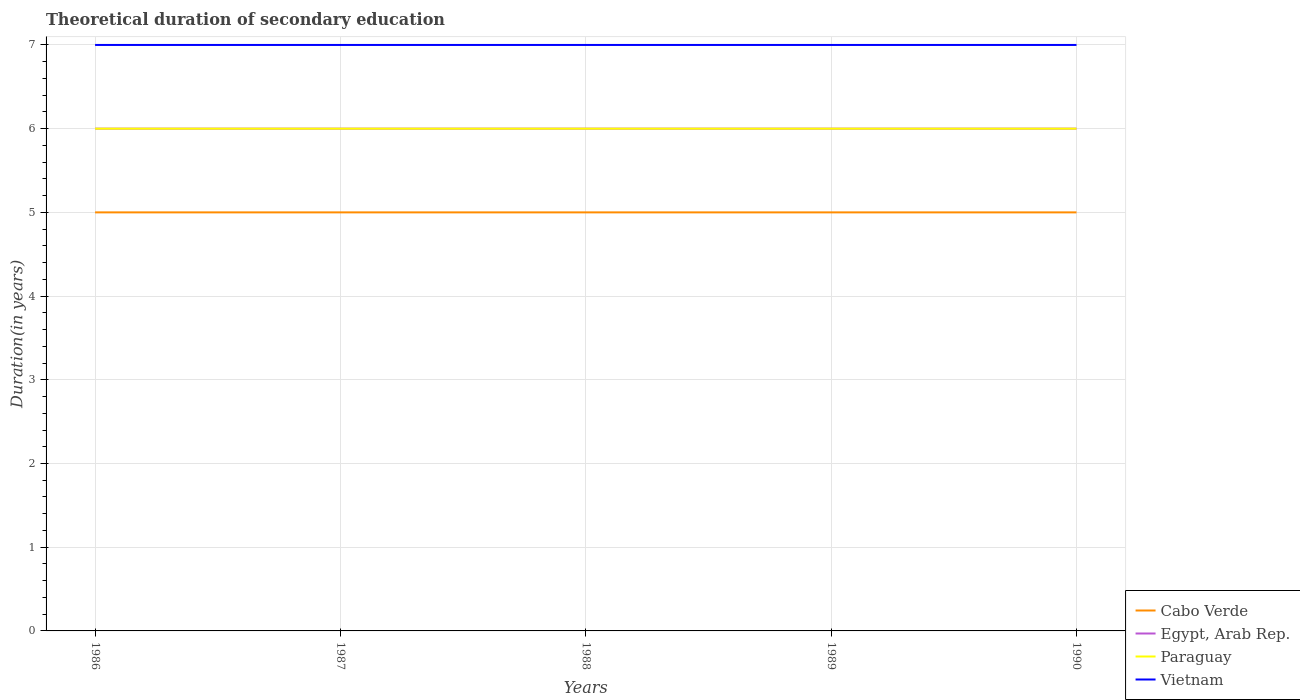Across all years, what is the maximum total theoretical duration of secondary education in Vietnam?
Your answer should be compact. 7. In which year was the total theoretical duration of secondary education in Egypt, Arab Rep. maximum?
Provide a succinct answer. 1986. Is the total theoretical duration of secondary education in Paraguay strictly greater than the total theoretical duration of secondary education in Egypt, Arab Rep. over the years?
Your answer should be compact. No. How many lines are there?
Provide a short and direct response. 4. What is the difference between two consecutive major ticks on the Y-axis?
Your answer should be very brief. 1. Are the values on the major ticks of Y-axis written in scientific E-notation?
Provide a short and direct response. No. How are the legend labels stacked?
Provide a short and direct response. Vertical. What is the title of the graph?
Offer a very short reply. Theoretical duration of secondary education. Does "Heavily indebted poor countries" appear as one of the legend labels in the graph?
Provide a short and direct response. No. What is the label or title of the Y-axis?
Provide a succinct answer. Duration(in years). What is the Duration(in years) in Cabo Verde in 1986?
Your answer should be very brief. 5. What is the Duration(in years) in Paraguay in 1986?
Your answer should be very brief. 6. What is the Duration(in years) of Vietnam in 1986?
Make the answer very short. 7. What is the Duration(in years) in Egypt, Arab Rep. in 1987?
Keep it short and to the point. 6. What is the Duration(in years) in Paraguay in 1987?
Your answer should be compact. 6. What is the Duration(in years) of Vietnam in 1987?
Provide a short and direct response. 7. What is the Duration(in years) of Egypt, Arab Rep. in 1988?
Provide a succinct answer. 6. What is the Duration(in years) of Paraguay in 1988?
Offer a very short reply. 6. What is the Duration(in years) in Paraguay in 1989?
Provide a short and direct response. 6. What is the Duration(in years) of Egypt, Arab Rep. in 1990?
Your answer should be very brief. 6. What is the Duration(in years) in Vietnam in 1990?
Keep it short and to the point. 7. Across all years, what is the maximum Duration(in years) of Cabo Verde?
Ensure brevity in your answer.  5. Across all years, what is the maximum Duration(in years) of Egypt, Arab Rep.?
Offer a very short reply. 6. Across all years, what is the minimum Duration(in years) of Paraguay?
Your answer should be very brief. 6. Across all years, what is the minimum Duration(in years) of Vietnam?
Make the answer very short. 7. What is the total Duration(in years) in Cabo Verde in the graph?
Make the answer very short. 25. What is the total Duration(in years) of Paraguay in the graph?
Your answer should be very brief. 30. What is the difference between the Duration(in years) of Egypt, Arab Rep. in 1986 and that in 1987?
Provide a short and direct response. 0. What is the difference between the Duration(in years) in Vietnam in 1986 and that in 1987?
Your response must be concise. 0. What is the difference between the Duration(in years) of Cabo Verde in 1986 and that in 1988?
Ensure brevity in your answer.  0. What is the difference between the Duration(in years) of Egypt, Arab Rep. in 1986 and that in 1988?
Provide a short and direct response. 0. What is the difference between the Duration(in years) in Paraguay in 1986 and that in 1988?
Provide a short and direct response. 0. What is the difference between the Duration(in years) of Vietnam in 1986 and that in 1988?
Provide a short and direct response. 0. What is the difference between the Duration(in years) in Cabo Verde in 1986 and that in 1989?
Your answer should be compact. 0. What is the difference between the Duration(in years) in Egypt, Arab Rep. in 1986 and that in 1989?
Give a very brief answer. 0. What is the difference between the Duration(in years) in Cabo Verde in 1986 and that in 1990?
Your answer should be compact. 0. What is the difference between the Duration(in years) in Egypt, Arab Rep. in 1986 and that in 1990?
Provide a succinct answer. 0. What is the difference between the Duration(in years) in Vietnam in 1986 and that in 1990?
Provide a succinct answer. 0. What is the difference between the Duration(in years) of Egypt, Arab Rep. in 1987 and that in 1988?
Make the answer very short. 0. What is the difference between the Duration(in years) of Paraguay in 1987 and that in 1988?
Offer a very short reply. 0. What is the difference between the Duration(in years) of Cabo Verde in 1987 and that in 1989?
Provide a short and direct response. 0. What is the difference between the Duration(in years) in Vietnam in 1987 and that in 1989?
Your answer should be very brief. 0. What is the difference between the Duration(in years) of Cabo Verde in 1987 and that in 1990?
Provide a succinct answer. 0. What is the difference between the Duration(in years) in Egypt, Arab Rep. in 1987 and that in 1990?
Make the answer very short. 0. What is the difference between the Duration(in years) of Paraguay in 1987 and that in 1990?
Provide a short and direct response. 0. What is the difference between the Duration(in years) in Egypt, Arab Rep. in 1988 and that in 1989?
Offer a very short reply. 0. What is the difference between the Duration(in years) in Vietnam in 1988 and that in 1989?
Give a very brief answer. 0. What is the difference between the Duration(in years) of Cabo Verde in 1988 and that in 1990?
Offer a terse response. 0. What is the difference between the Duration(in years) in Vietnam in 1988 and that in 1990?
Ensure brevity in your answer.  0. What is the difference between the Duration(in years) of Cabo Verde in 1986 and the Duration(in years) of Egypt, Arab Rep. in 1987?
Your answer should be compact. -1. What is the difference between the Duration(in years) of Cabo Verde in 1986 and the Duration(in years) of Paraguay in 1987?
Your answer should be compact. -1. What is the difference between the Duration(in years) in Cabo Verde in 1986 and the Duration(in years) in Vietnam in 1987?
Give a very brief answer. -2. What is the difference between the Duration(in years) of Egypt, Arab Rep. in 1986 and the Duration(in years) of Vietnam in 1987?
Offer a very short reply. -1. What is the difference between the Duration(in years) in Paraguay in 1986 and the Duration(in years) in Vietnam in 1987?
Keep it short and to the point. -1. What is the difference between the Duration(in years) of Cabo Verde in 1986 and the Duration(in years) of Paraguay in 1988?
Your answer should be compact. -1. What is the difference between the Duration(in years) in Egypt, Arab Rep. in 1986 and the Duration(in years) in Paraguay in 1988?
Ensure brevity in your answer.  0. What is the difference between the Duration(in years) of Egypt, Arab Rep. in 1986 and the Duration(in years) of Vietnam in 1988?
Keep it short and to the point. -1. What is the difference between the Duration(in years) in Cabo Verde in 1986 and the Duration(in years) in Egypt, Arab Rep. in 1989?
Offer a very short reply. -1. What is the difference between the Duration(in years) of Cabo Verde in 1986 and the Duration(in years) of Paraguay in 1989?
Your response must be concise. -1. What is the difference between the Duration(in years) in Egypt, Arab Rep. in 1986 and the Duration(in years) in Vietnam in 1989?
Make the answer very short. -1. What is the difference between the Duration(in years) in Paraguay in 1986 and the Duration(in years) in Vietnam in 1989?
Make the answer very short. -1. What is the difference between the Duration(in years) in Cabo Verde in 1986 and the Duration(in years) in Paraguay in 1990?
Offer a terse response. -1. What is the difference between the Duration(in years) of Cabo Verde in 1986 and the Duration(in years) of Vietnam in 1990?
Your answer should be compact. -2. What is the difference between the Duration(in years) of Egypt, Arab Rep. in 1986 and the Duration(in years) of Paraguay in 1990?
Your response must be concise. 0. What is the difference between the Duration(in years) of Paraguay in 1986 and the Duration(in years) of Vietnam in 1990?
Keep it short and to the point. -1. What is the difference between the Duration(in years) in Cabo Verde in 1987 and the Duration(in years) in Egypt, Arab Rep. in 1988?
Your answer should be compact. -1. What is the difference between the Duration(in years) in Egypt, Arab Rep. in 1987 and the Duration(in years) in Paraguay in 1988?
Offer a very short reply. 0. What is the difference between the Duration(in years) of Egypt, Arab Rep. in 1987 and the Duration(in years) of Vietnam in 1988?
Provide a short and direct response. -1. What is the difference between the Duration(in years) of Paraguay in 1987 and the Duration(in years) of Vietnam in 1988?
Provide a succinct answer. -1. What is the difference between the Duration(in years) in Paraguay in 1987 and the Duration(in years) in Vietnam in 1989?
Provide a short and direct response. -1. What is the difference between the Duration(in years) in Cabo Verde in 1987 and the Duration(in years) in Egypt, Arab Rep. in 1990?
Your answer should be compact. -1. What is the difference between the Duration(in years) in Cabo Verde in 1987 and the Duration(in years) in Paraguay in 1990?
Your answer should be compact. -1. What is the difference between the Duration(in years) in Paraguay in 1987 and the Duration(in years) in Vietnam in 1990?
Offer a very short reply. -1. What is the difference between the Duration(in years) of Cabo Verde in 1988 and the Duration(in years) of Paraguay in 1989?
Your answer should be compact. -1. What is the difference between the Duration(in years) of Cabo Verde in 1988 and the Duration(in years) of Vietnam in 1989?
Your answer should be very brief. -2. What is the difference between the Duration(in years) of Egypt, Arab Rep. in 1988 and the Duration(in years) of Paraguay in 1989?
Make the answer very short. 0. What is the difference between the Duration(in years) of Egypt, Arab Rep. in 1988 and the Duration(in years) of Vietnam in 1989?
Give a very brief answer. -1. What is the difference between the Duration(in years) of Cabo Verde in 1988 and the Duration(in years) of Egypt, Arab Rep. in 1990?
Ensure brevity in your answer.  -1. What is the difference between the Duration(in years) of Egypt, Arab Rep. in 1988 and the Duration(in years) of Paraguay in 1990?
Your response must be concise. 0. What is the difference between the Duration(in years) in Egypt, Arab Rep. in 1988 and the Duration(in years) in Vietnam in 1990?
Provide a short and direct response. -1. What is the difference between the Duration(in years) of Egypt, Arab Rep. in 1989 and the Duration(in years) of Paraguay in 1990?
Your answer should be very brief. 0. What is the difference between the Duration(in years) in Egypt, Arab Rep. in 1989 and the Duration(in years) in Vietnam in 1990?
Offer a terse response. -1. What is the difference between the Duration(in years) in Paraguay in 1989 and the Duration(in years) in Vietnam in 1990?
Give a very brief answer. -1. What is the average Duration(in years) of Egypt, Arab Rep. per year?
Your answer should be very brief. 6. In the year 1986, what is the difference between the Duration(in years) in Cabo Verde and Duration(in years) in Egypt, Arab Rep.?
Offer a terse response. -1. In the year 1986, what is the difference between the Duration(in years) of Cabo Verde and Duration(in years) of Paraguay?
Ensure brevity in your answer.  -1. In the year 1986, what is the difference between the Duration(in years) in Paraguay and Duration(in years) in Vietnam?
Your answer should be compact. -1. In the year 1987, what is the difference between the Duration(in years) of Cabo Verde and Duration(in years) of Paraguay?
Offer a very short reply. -1. In the year 1987, what is the difference between the Duration(in years) of Cabo Verde and Duration(in years) of Vietnam?
Offer a terse response. -2. In the year 1987, what is the difference between the Duration(in years) of Egypt, Arab Rep. and Duration(in years) of Paraguay?
Provide a short and direct response. 0. In the year 1987, what is the difference between the Duration(in years) of Egypt, Arab Rep. and Duration(in years) of Vietnam?
Your response must be concise. -1. In the year 1987, what is the difference between the Duration(in years) in Paraguay and Duration(in years) in Vietnam?
Your response must be concise. -1. In the year 1988, what is the difference between the Duration(in years) in Cabo Verde and Duration(in years) in Paraguay?
Keep it short and to the point. -1. In the year 1988, what is the difference between the Duration(in years) in Cabo Verde and Duration(in years) in Vietnam?
Keep it short and to the point. -2. In the year 1988, what is the difference between the Duration(in years) of Egypt, Arab Rep. and Duration(in years) of Paraguay?
Provide a short and direct response. 0. In the year 1988, what is the difference between the Duration(in years) of Egypt, Arab Rep. and Duration(in years) of Vietnam?
Your answer should be compact. -1. In the year 1988, what is the difference between the Duration(in years) of Paraguay and Duration(in years) of Vietnam?
Your answer should be compact. -1. In the year 1989, what is the difference between the Duration(in years) of Cabo Verde and Duration(in years) of Vietnam?
Your answer should be compact. -2. In the year 1990, what is the difference between the Duration(in years) in Cabo Verde and Duration(in years) in Egypt, Arab Rep.?
Offer a terse response. -1. In the year 1990, what is the difference between the Duration(in years) in Cabo Verde and Duration(in years) in Paraguay?
Offer a terse response. -1. What is the ratio of the Duration(in years) of Vietnam in 1986 to that in 1988?
Ensure brevity in your answer.  1. What is the ratio of the Duration(in years) in Cabo Verde in 1986 to that in 1989?
Your answer should be very brief. 1. What is the ratio of the Duration(in years) of Cabo Verde in 1986 to that in 1990?
Make the answer very short. 1. What is the ratio of the Duration(in years) in Egypt, Arab Rep. in 1986 to that in 1990?
Your response must be concise. 1. What is the ratio of the Duration(in years) of Vietnam in 1986 to that in 1990?
Your answer should be compact. 1. What is the ratio of the Duration(in years) of Cabo Verde in 1987 to that in 1988?
Provide a short and direct response. 1. What is the ratio of the Duration(in years) in Egypt, Arab Rep. in 1987 to that in 1988?
Keep it short and to the point. 1. What is the ratio of the Duration(in years) in Paraguay in 1987 to that in 1988?
Your answer should be compact. 1. What is the ratio of the Duration(in years) in Vietnam in 1987 to that in 1988?
Keep it short and to the point. 1. What is the ratio of the Duration(in years) of Cabo Verde in 1987 to that in 1990?
Give a very brief answer. 1. What is the ratio of the Duration(in years) in Egypt, Arab Rep. in 1987 to that in 1990?
Provide a short and direct response. 1. What is the ratio of the Duration(in years) of Vietnam in 1987 to that in 1990?
Make the answer very short. 1. What is the ratio of the Duration(in years) of Cabo Verde in 1988 to that in 1989?
Offer a terse response. 1. What is the ratio of the Duration(in years) in Paraguay in 1989 to that in 1990?
Provide a succinct answer. 1. What is the difference between the highest and the second highest Duration(in years) of Paraguay?
Offer a very short reply. 0. What is the difference between the highest and the lowest Duration(in years) of Egypt, Arab Rep.?
Ensure brevity in your answer.  0. What is the difference between the highest and the lowest Duration(in years) of Paraguay?
Provide a succinct answer. 0. 